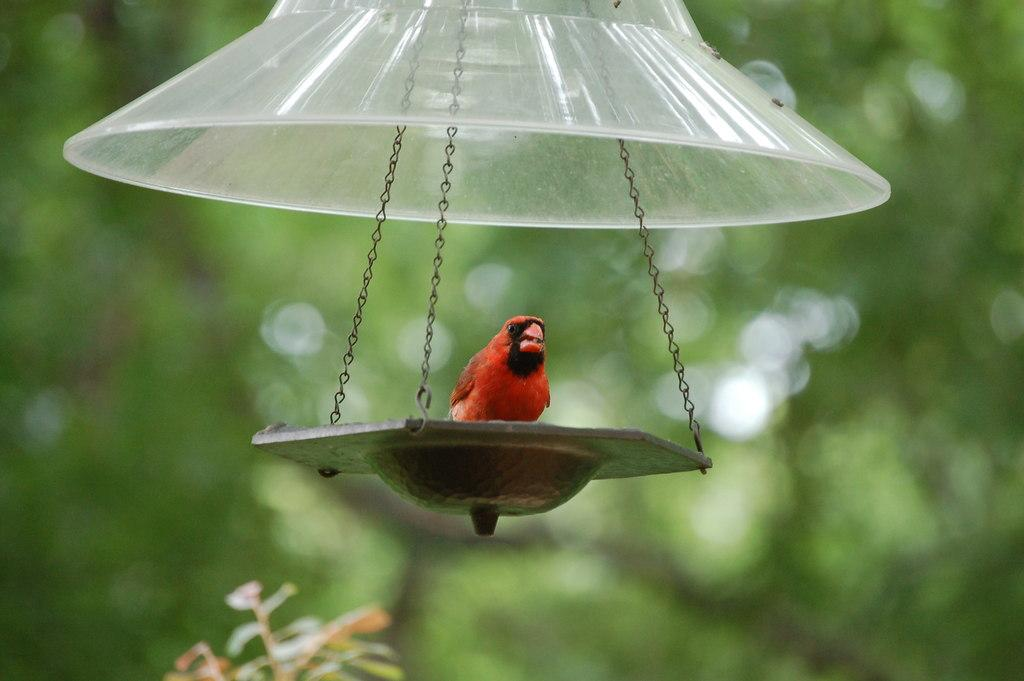What type of animal can be seen in the image? There is a bird in the image. Where is the bird located in the image? The bird is sitting on a hanging bird feeder. What can be seen in the background of the image? There are trees visible in the background of the image. What type of lunchroom can be seen in the image? There is no lunchroom present in the image; it features a bird sitting on a hanging bird feeder with trees in the background. Can you describe the bird's tongue in the image? There is no information about the bird's tongue in the image, as it only shows the bird sitting on a hanging bird feeder. 